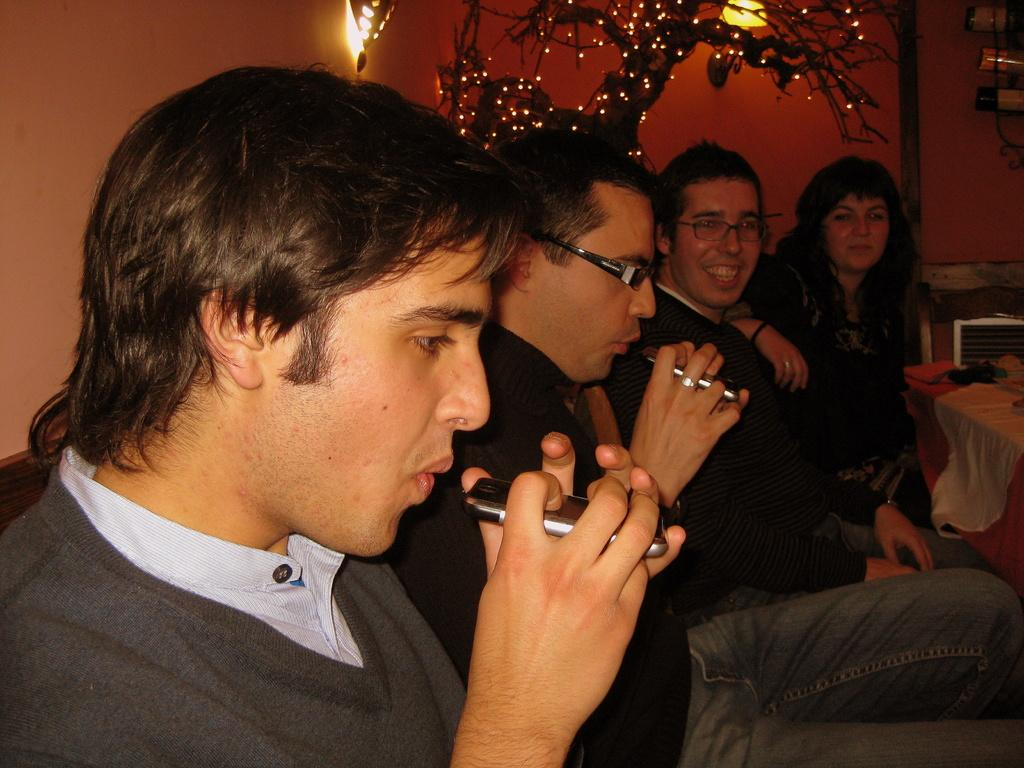How many people are in the group shown in the image? There is a group of people in the image, but the exact number is not specified. Can you describe the facial expression of one of the people in the group? One person in the group is smiling. What can be seen in the background of the image? There is a plant and lights visible in the background of the image. How many mice are running across the table in the image? There are no mice present in the image. What is the middle person in the group doing in the image? The facts provided do not specify the position of the people in the group, so it is not possible to determine who the middle person is or what they are doing. 